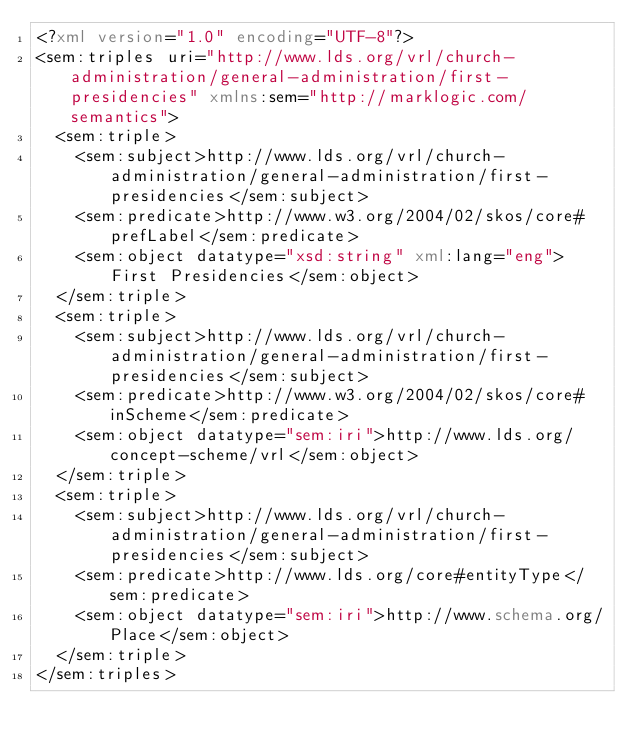Convert code to text. <code><loc_0><loc_0><loc_500><loc_500><_XML_><?xml version="1.0" encoding="UTF-8"?>
<sem:triples uri="http://www.lds.org/vrl/church-administration/general-administration/first-presidencies" xmlns:sem="http://marklogic.com/semantics">
  <sem:triple>
    <sem:subject>http://www.lds.org/vrl/church-administration/general-administration/first-presidencies</sem:subject>
    <sem:predicate>http://www.w3.org/2004/02/skos/core#prefLabel</sem:predicate>
    <sem:object datatype="xsd:string" xml:lang="eng">First Presidencies</sem:object>
  </sem:triple>
  <sem:triple>
    <sem:subject>http://www.lds.org/vrl/church-administration/general-administration/first-presidencies</sem:subject>
    <sem:predicate>http://www.w3.org/2004/02/skos/core#inScheme</sem:predicate>
    <sem:object datatype="sem:iri">http://www.lds.org/concept-scheme/vrl</sem:object>
  </sem:triple>
  <sem:triple>
    <sem:subject>http://www.lds.org/vrl/church-administration/general-administration/first-presidencies</sem:subject>
    <sem:predicate>http://www.lds.org/core#entityType</sem:predicate>
    <sem:object datatype="sem:iri">http://www.schema.org/Place</sem:object>
  </sem:triple>
</sem:triples>
</code> 